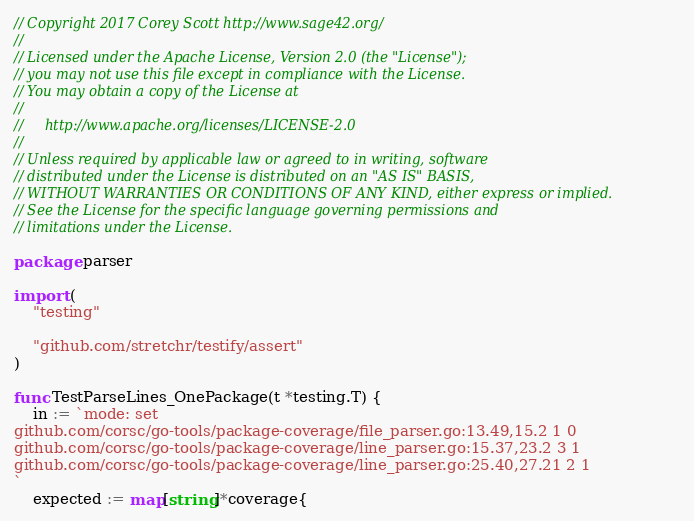<code> <loc_0><loc_0><loc_500><loc_500><_Go_>// Copyright 2017 Corey Scott http://www.sage42.org/
//
// Licensed under the Apache License, Version 2.0 (the "License");
// you may not use this file except in compliance with the License.
// You may obtain a copy of the License at
//
//     http://www.apache.org/licenses/LICENSE-2.0
//
// Unless required by applicable law or agreed to in writing, software
// distributed under the License is distributed on an "AS IS" BASIS,
// WITHOUT WARRANTIES OR CONDITIONS OF ANY KIND, either express or implied.
// See the License for the specific language governing permissions and
// limitations under the License.

package parser

import (
	"testing"

	"github.com/stretchr/testify/assert"
)

func TestParseLines_OnePackage(t *testing.T) {
	in := `mode: set
github.com/corsc/go-tools/package-coverage/file_parser.go:13.49,15.2 1 0
github.com/corsc/go-tools/package-coverage/line_parser.go:15.37,23.2 3 1
github.com/corsc/go-tools/package-coverage/line_parser.go:25.40,27.21 2 1
`
	expected := map[string]*coverage{</code> 